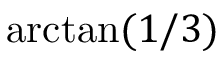Convert formula to latex. <formula><loc_0><loc_0><loc_500><loc_500>\arctan ( 1 / 3 )</formula> 